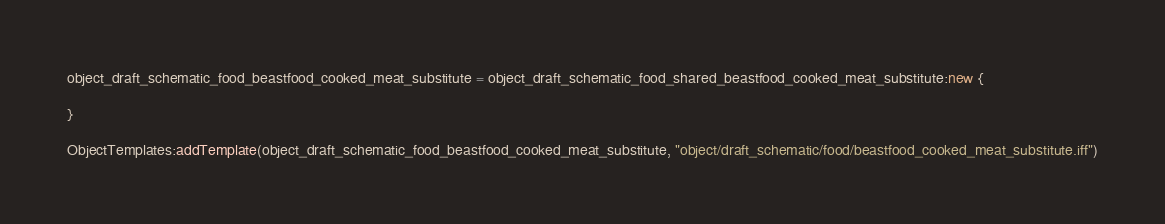Convert code to text. <code><loc_0><loc_0><loc_500><loc_500><_Lua_>object_draft_schematic_food_beastfood_cooked_meat_substitute = object_draft_schematic_food_shared_beastfood_cooked_meat_substitute:new {

}

ObjectTemplates:addTemplate(object_draft_schematic_food_beastfood_cooked_meat_substitute, "object/draft_schematic/food/beastfood_cooked_meat_substitute.iff")
</code> 